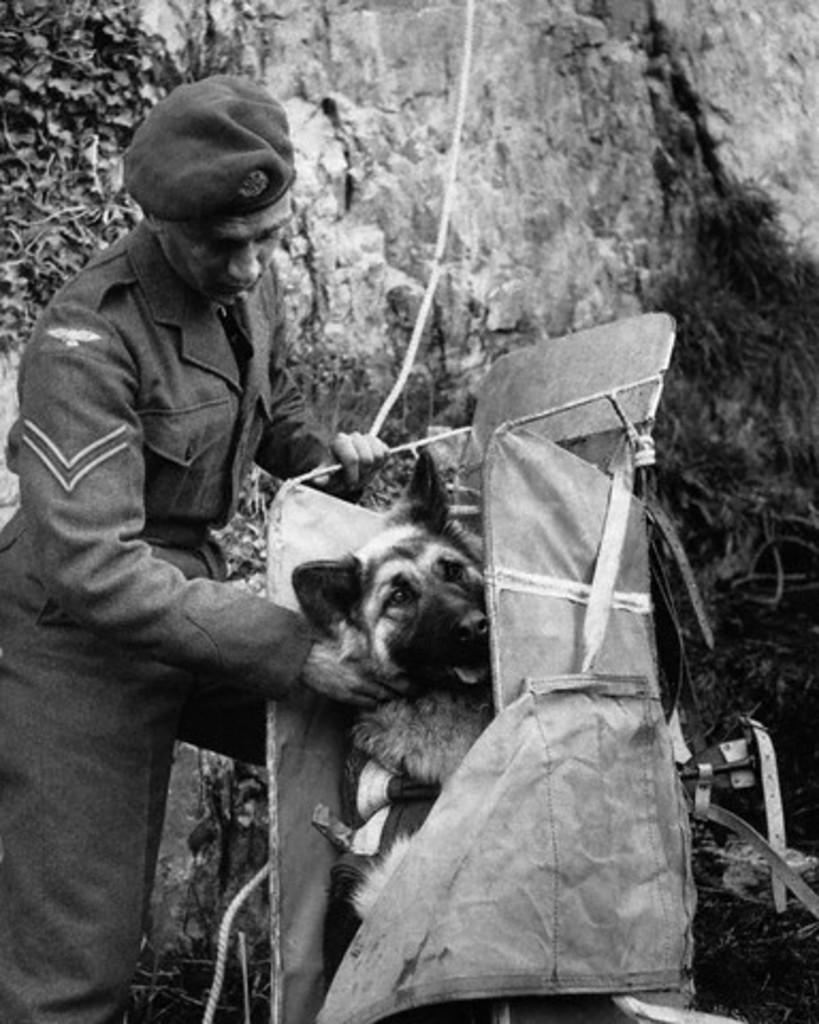What is the main subject of the image? The main subject of the image is a man. What is the man doing in the image? The man is standing and holding a dog. How is the dog being carried by the man? The dog is in a bag. What can be seen in the background of the image? There is a rock in the background of the image. What is the man wearing in the image? The man is wearing a uniform and a cap. What type of scent does the vegetable in the image emit? There is no vegetable present in the image, so it is not possible to determine the scent it might emit. 